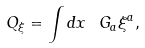Convert formula to latex. <formula><loc_0><loc_0><loc_500><loc_500>Q _ { \xi } = \int d x \ G _ { a } \xi ^ { a } ,</formula> 